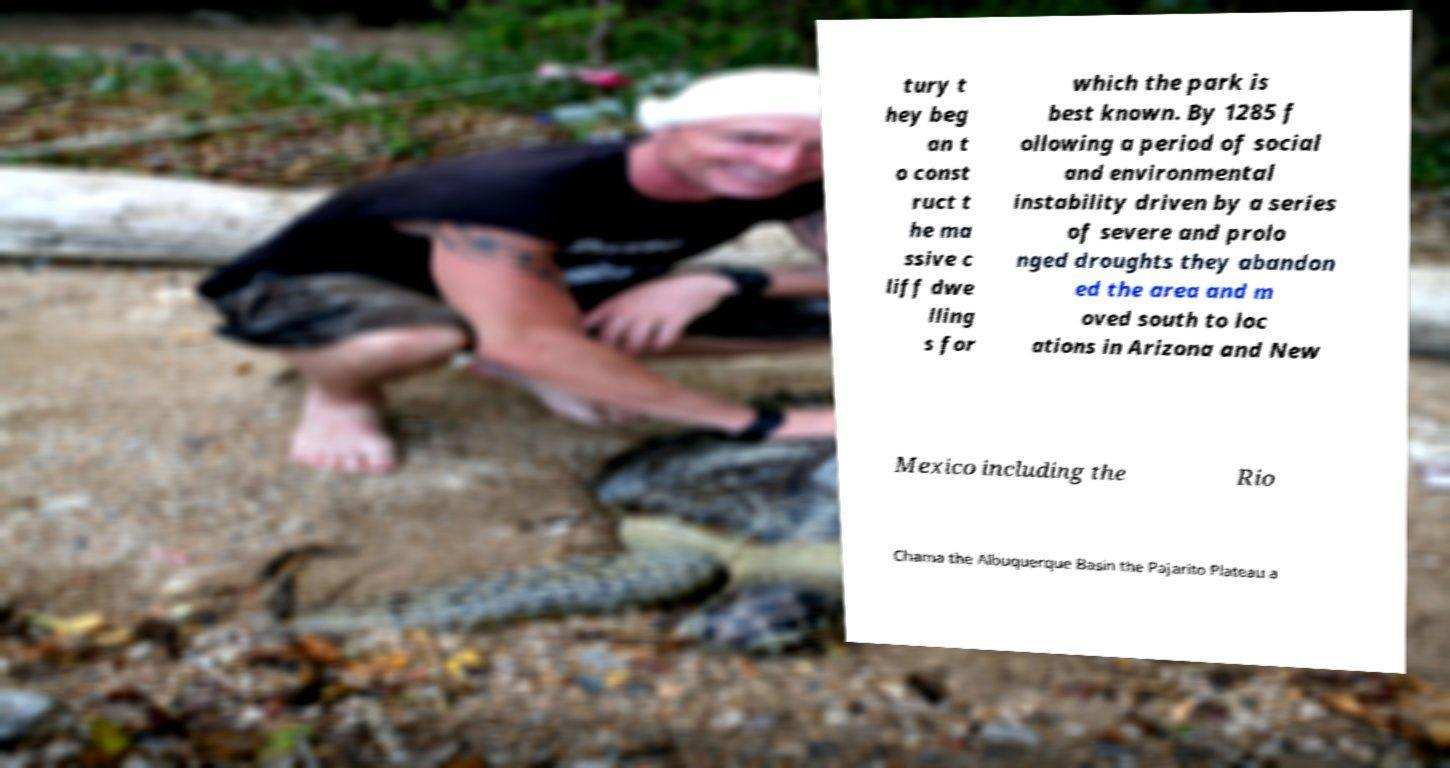Can you accurately transcribe the text from the provided image for me? tury t hey beg an t o const ruct t he ma ssive c liff dwe lling s for which the park is best known. By 1285 f ollowing a period of social and environmental instability driven by a series of severe and prolo nged droughts they abandon ed the area and m oved south to loc ations in Arizona and New Mexico including the Rio Chama the Albuquerque Basin the Pajarito Plateau a 